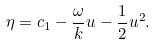Convert formula to latex. <formula><loc_0><loc_0><loc_500><loc_500>\eta = c _ { 1 } - \frac { \omega } { k } u - \frac { 1 } { 2 } u ^ { 2 } .</formula> 